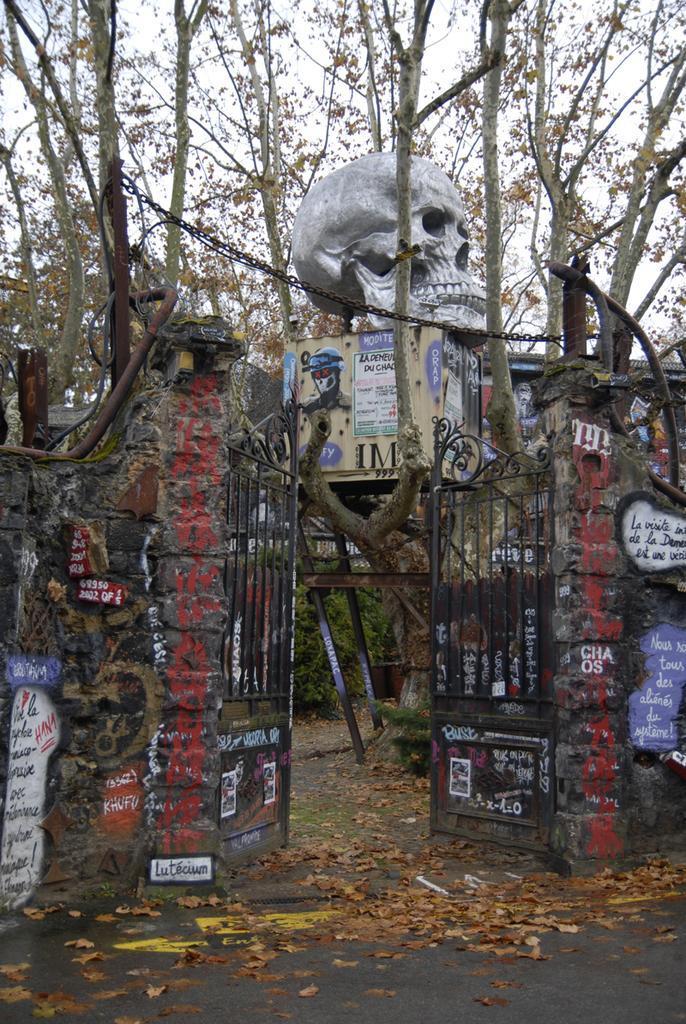How would you summarize this image in a sentence or two? In this picture there is a gate in the center of the image and there is a skull at the top side of the image and there are trees in the background area of the image. 